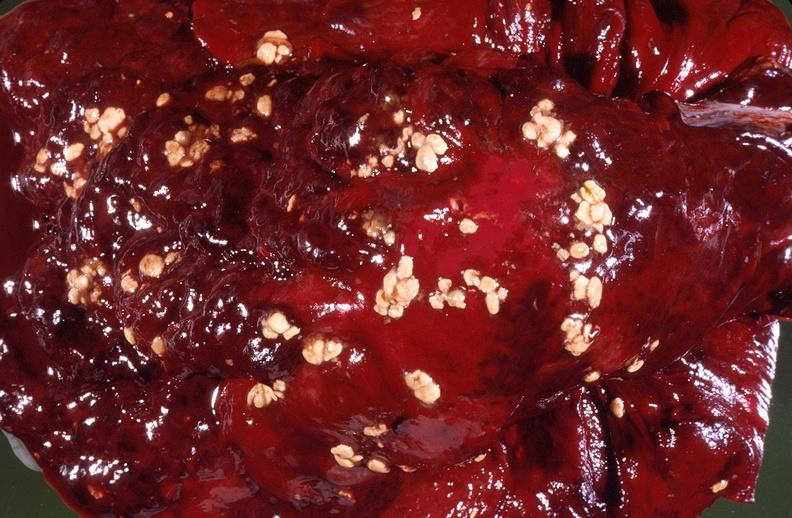s respiratory present?
Answer the question using a single word or phrase. Yes 